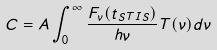Convert formula to latex. <formula><loc_0><loc_0><loc_500><loc_500>C = A \int _ { 0 } ^ { \infty } \frac { F _ { \nu } ( t _ { S T I S } ) } { h \nu } T ( \nu ) d \nu</formula> 